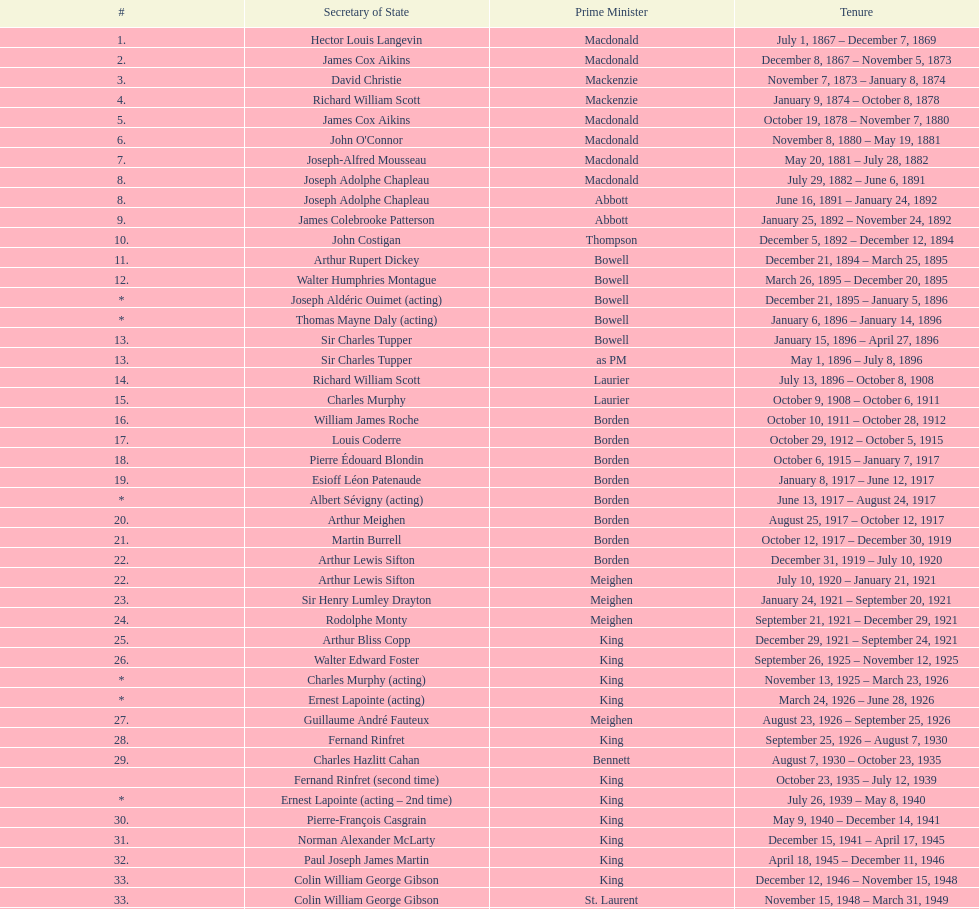Who held the position of secretary of state under thompson? John Costigan. 